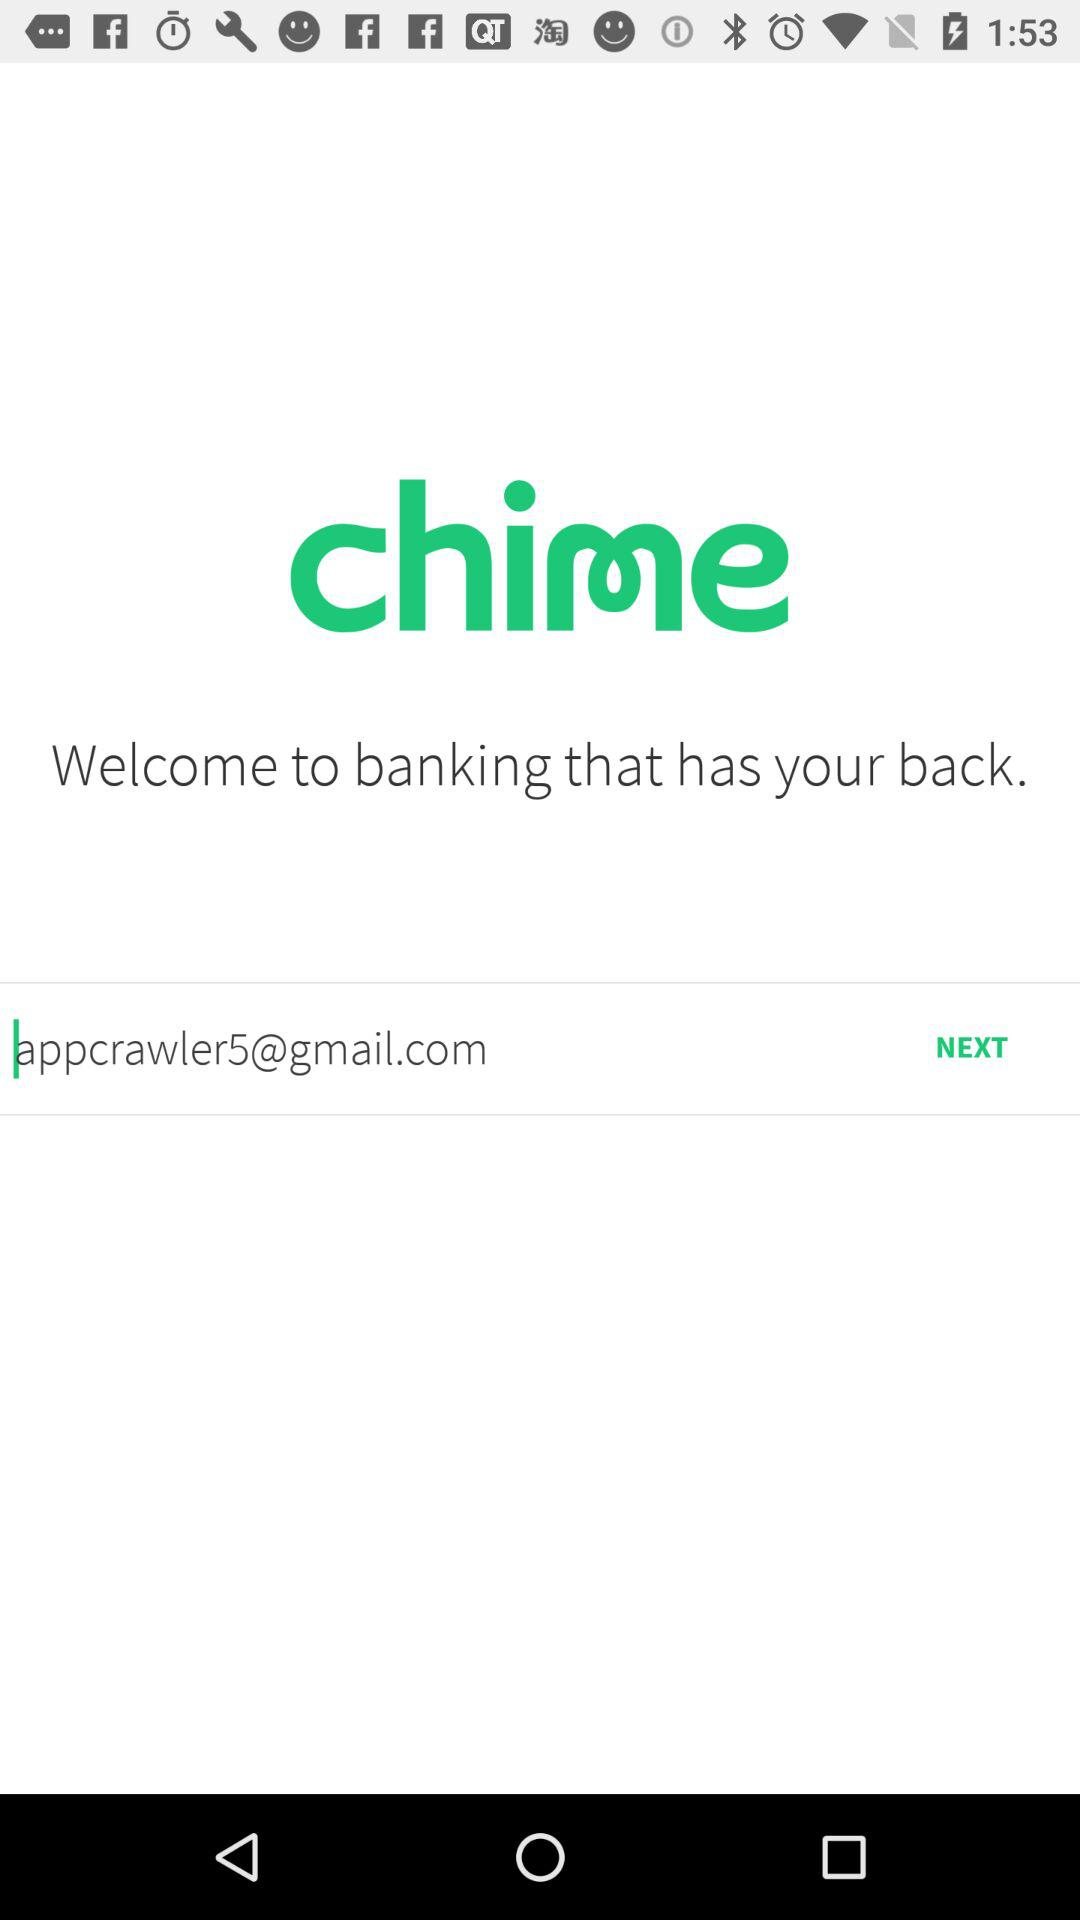What is the name of the application? The name of the application is "chime". 